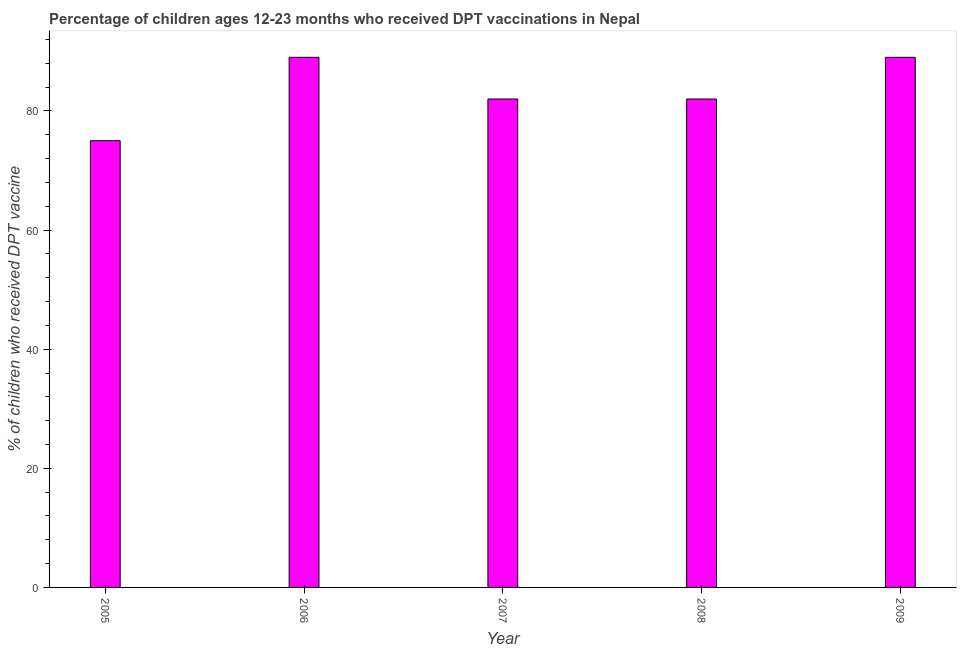Does the graph contain grids?
Keep it short and to the point. No. What is the title of the graph?
Offer a terse response. Percentage of children ages 12-23 months who received DPT vaccinations in Nepal. What is the label or title of the X-axis?
Provide a succinct answer. Year. What is the label or title of the Y-axis?
Your answer should be compact. % of children who received DPT vaccine. What is the percentage of children who received dpt vaccine in 2009?
Make the answer very short. 89. Across all years, what is the maximum percentage of children who received dpt vaccine?
Your response must be concise. 89. In which year was the percentage of children who received dpt vaccine minimum?
Offer a terse response. 2005. What is the sum of the percentage of children who received dpt vaccine?
Offer a terse response. 417. What is the difference between the percentage of children who received dpt vaccine in 2008 and 2009?
Keep it short and to the point. -7. What is the median percentage of children who received dpt vaccine?
Provide a succinct answer. 82. In how many years, is the percentage of children who received dpt vaccine greater than 8 %?
Provide a short and direct response. 5. What is the ratio of the percentage of children who received dpt vaccine in 2005 to that in 2008?
Ensure brevity in your answer.  0.92. Is the percentage of children who received dpt vaccine in 2008 less than that in 2009?
Your response must be concise. Yes. What is the difference between the highest and the second highest percentage of children who received dpt vaccine?
Provide a short and direct response. 0. What is the difference between the highest and the lowest percentage of children who received dpt vaccine?
Make the answer very short. 14. In how many years, is the percentage of children who received dpt vaccine greater than the average percentage of children who received dpt vaccine taken over all years?
Ensure brevity in your answer.  2. How many bars are there?
Offer a terse response. 5. Are all the bars in the graph horizontal?
Your answer should be very brief. No. How many years are there in the graph?
Ensure brevity in your answer.  5. What is the difference between two consecutive major ticks on the Y-axis?
Ensure brevity in your answer.  20. What is the % of children who received DPT vaccine in 2006?
Keep it short and to the point. 89. What is the % of children who received DPT vaccine of 2007?
Give a very brief answer. 82. What is the % of children who received DPT vaccine in 2008?
Your answer should be compact. 82. What is the % of children who received DPT vaccine in 2009?
Give a very brief answer. 89. What is the difference between the % of children who received DPT vaccine in 2005 and 2006?
Your response must be concise. -14. What is the difference between the % of children who received DPT vaccine in 2005 and 2007?
Your response must be concise. -7. What is the difference between the % of children who received DPT vaccine in 2006 and 2009?
Offer a terse response. 0. What is the difference between the % of children who received DPT vaccine in 2007 and 2009?
Give a very brief answer. -7. What is the ratio of the % of children who received DPT vaccine in 2005 to that in 2006?
Keep it short and to the point. 0.84. What is the ratio of the % of children who received DPT vaccine in 2005 to that in 2007?
Provide a short and direct response. 0.92. What is the ratio of the % of children who received DPT vaccine in 2005 to that in 2008?
Your response must be concise. 0.92. What is the ratio of the % of children who received DPT vaccine in 2005 to that in 2009?
Your answer should be very brief. 0.84. What is the ratio of the % of children who received DPT vaccine in 2006 to that in 2007?
Make the answer very short. 1.08. What is the ratio of the % of children who received DPT vaccine in 2006 to that in 2008?
Offer a very short reply. 1.08. What is the ratio of the % of children who received DPT vaccine in 2007 to that in 2008?
Provide a succinct answer. 1. What is the ratio of the % of children who received DPT vaccine in 2007 to that in 2009?
Offer a very short reply. 0.92. What is the ratio of the % of children who received DPT vaccine in 2008 to that in 2009?
Ensure brevity in your answer.  0.92. 